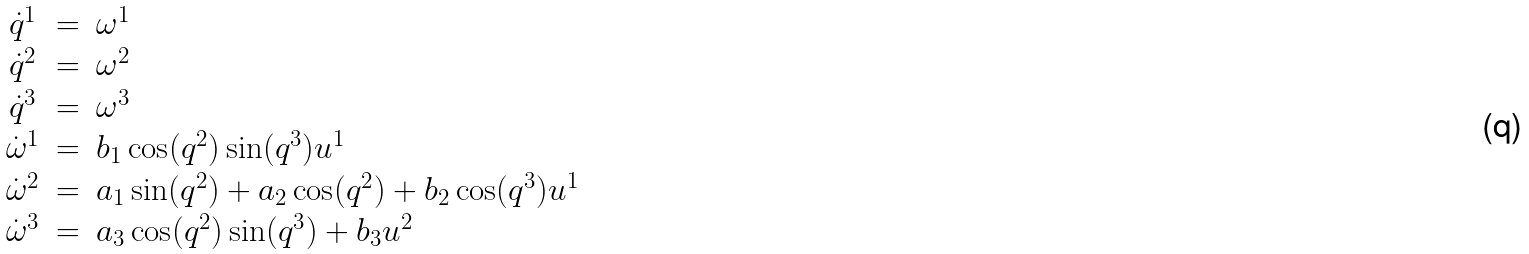<formula> <loc_0><loc_0><loc_500><loc_500>\begin{array} { c c l } \dot { q } ^ { 1 } & = & \omega ^ { 1 } \\ \dot { q } ^ { 2 } & = & \omega ^ { 2 } \\ \dot { q } ^ { 3 } & = & \omega ^ { 3 } \\ \dot { \omega } ^ { 1 } & = & b _ { 1 } \cos ( q ^ { 2 } ) \sin ( q ^ { 3 } ) u ^ { 1 } \\ \dot { \omega } ^ { 2 } & = & a _ { 1 } \sin ( q ^ { 2 } ) + a _ { 2 } \cos ( q ^ { 2 } ) + b _ { 2 } \cos ( q ^ { 3 } ) u ^ { 1 } \\ \dot { \omega } ^ { 3 } & = & a _ { 3 } \cos ( q ^ { 2 } ) \sin ( q ^ { 3 } ) + b _ { 3 } u ^ { 2 } \end{array}</formula> 